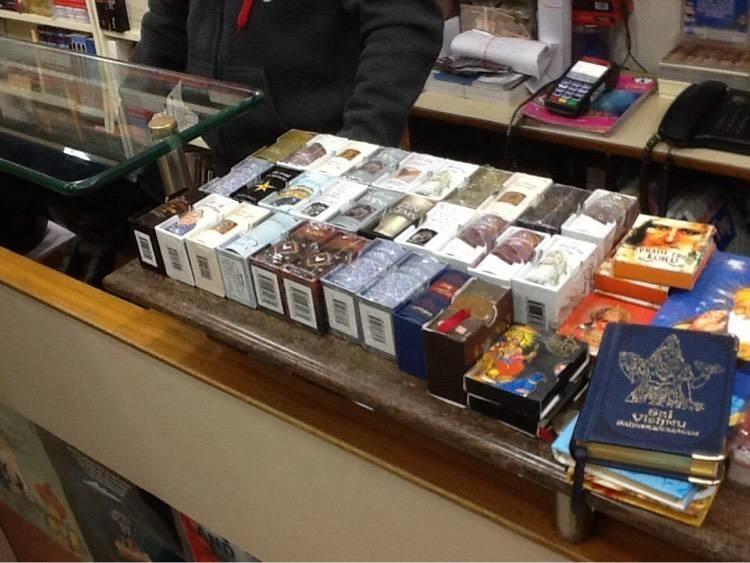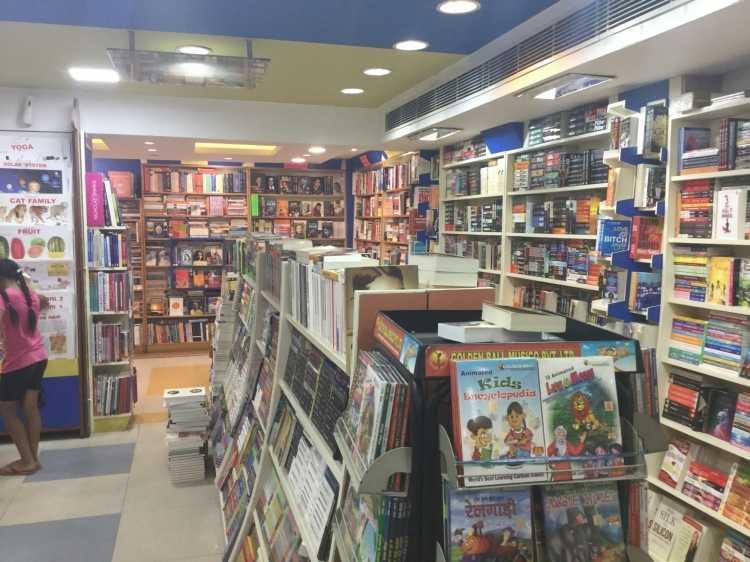The first image is the image on the left, the second image is the image on the right. For the images shown, is this caption "One image is taken from outside the shop." true? Answer yes or no. No. The first image is the image on the left, the second image is the image on the right. Given the left and right images, does the statement "The exterior of a bookshop with plate glass windows is seen in one image, while a second image shows interior racks of books." hold true? Answer yes or no. No. 